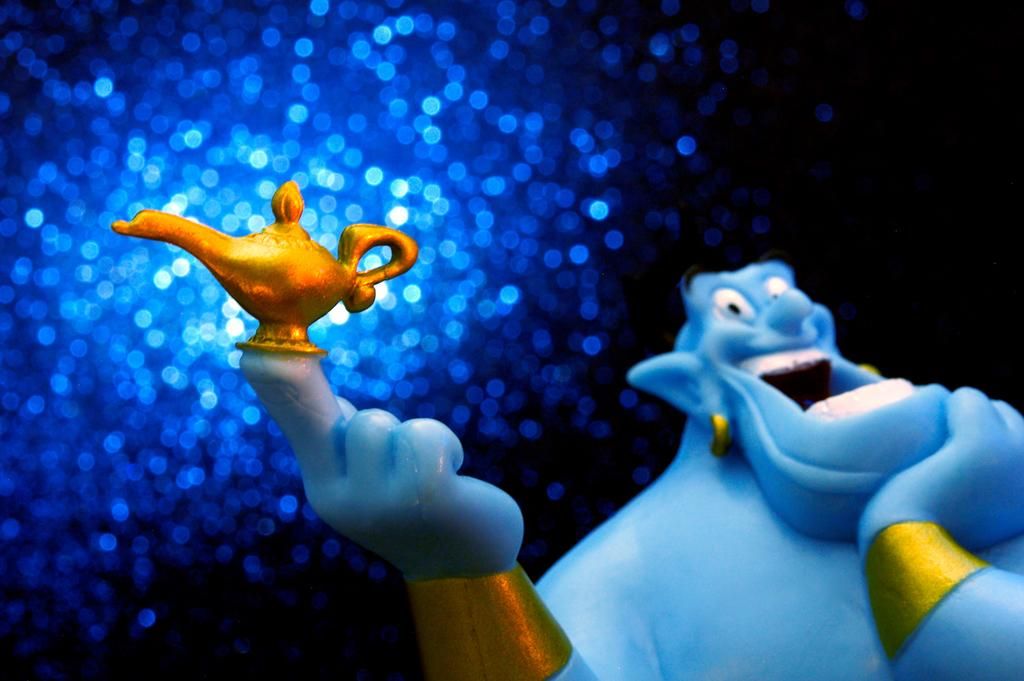What is the main subject of the image? The main subject of the image is a genie holding a lamp. What is the genie doing with the lamp? The genie is holding the lamp, but the image does not show any specific action being performed with it. What can be seen in the background of the image? There are sprinkles of light in the sky in the background of the image, and the sky is described as sky blue. What type of marble is used to create the spot on the genie's robe? There is no marble or spot visible on the genie's robe in the image. 